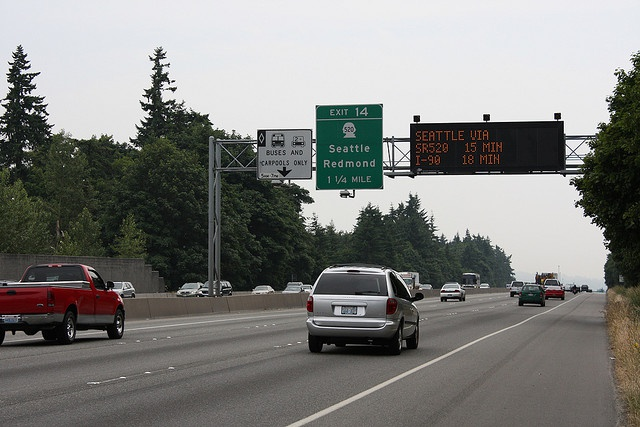Describe the objects in this image and their specific colors. I can see car in lightgray, black, maroon, gray, and darkgray tones, car in lightgray, black, gray, and darkgray tones, truck in lightgray, black, maroon, gray, and darkgray tones, car in lightgray, black, gray, teal, and darkgray tones, and car in lightgray, black, gray, and darkgray tones in this image. 